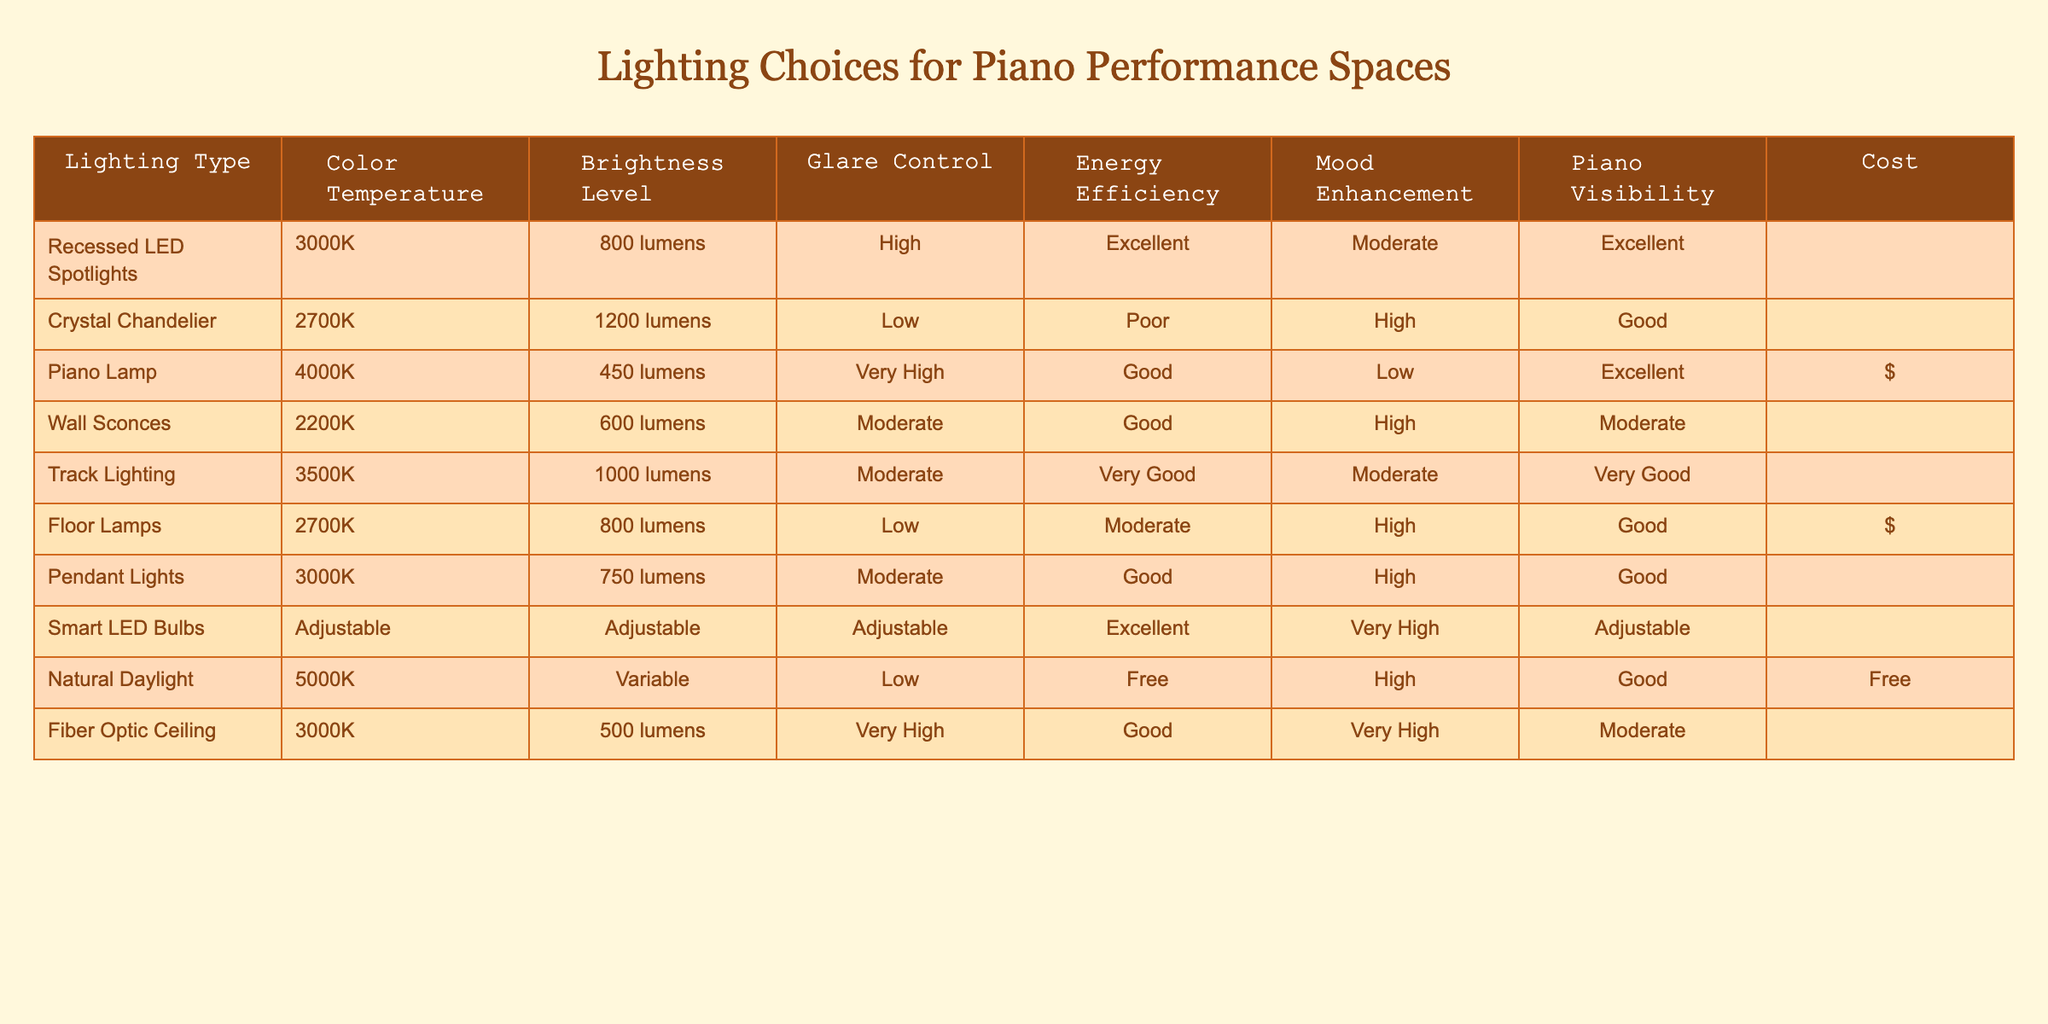What is the color temperature of the Crystal Chandelier? The table shows the Crystal Chandelier has a color temperature listed as 2700K.
Answer: 2700K Which lighting option has the highest brightness level? By comparing the brightness levels in the table, the Crystal Chandelier has the highest brightness at 1200 lumens.
Answer: 1200 lumens Is the glare control for the Piano Lamp very high? The table states that the glare control for the Piano Lamp is classified as very high, which indicates it effectively reduces glare.
Answer: No What is the cost of using Natural Daylight for lighting? The table indicates that the cost for Natural Daylight is free, making it the most cost-effective option listed.
Answer: Free Which lighting option provides the best energy efficiency according to the table? The table shows that the Recessed LED Spotlights have an energy efficiency rating of excellent, which is the best among the options.
Answer: Excellent What is the average brightness level of the wall sconces and track lighting? The brightness level for wall sconces is 600 lumens and track lighting is 1000 lumens. The average is (600 + 1000) / 2 = 800 lumens.
Answer: 800 lumens Is there a lighting option with adjustable characteristics? The table lists Smart LED Bulbs as having adjustable characteristics for color temperature and brightness levels, indicating it qualifies based on the inquiry.
Answer: Yes Which two options have low glare control but high mood enhancement? Looking at the table, both Floor Lamps (low glare, high mood enhancement) and Crystal Chandelier (low glare, high mood enhancement) meet this criterion.
Answer: Floor Lamps, Crystal Chandelier What lighting choice has the best piano visibility but moderate glare control? The Track Lighting offers very good piano visibility paired with moderate glare control, thus fulfilling the requirement.
Answer: Track Lighting 